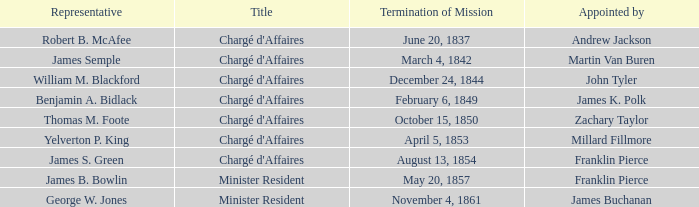What Title has a Termination of Mission for August 13, 1854? Chargé d'Affaires. 